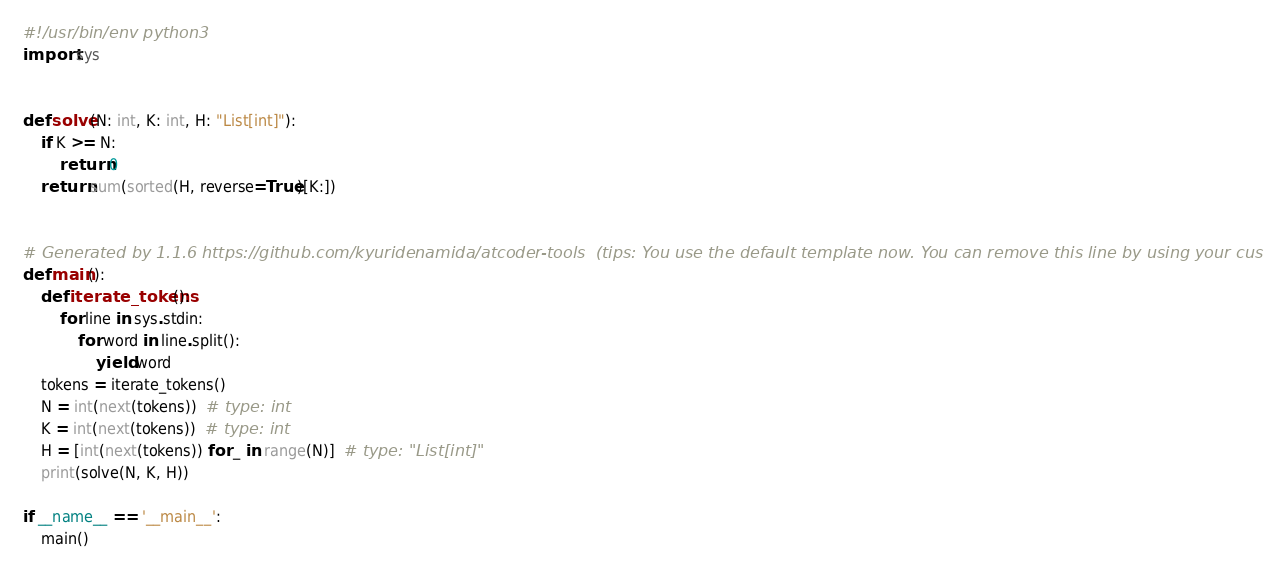Convert code to text. <code><loc_0><loc_0><loc_500><loc_500><_Python_>#!/usr/bin/env python3
import sys


def solve(N: int, K: int, H: "List[int]"):
    if K >= N:
        return 0
    return sum(sorted(H, reverse=True)[K:])


# Generated by 1.1.6 https://github.com/kyuridenamida/atcoder-tools  (tips: You use the default template now. You can remove this line by using your custom template)
def main():
    def iterate_tokens():
        for line in sys.stdin:
            for word in line.split():
                yield word
    tokens = iterate_tokens()
    N = int(next(tokens))  # type: int
    K = int(next(tokens))  # type: int
    H = [int(next(tokens)) for _ in range(N)]  # type: "List[int]"
    print(solve(N, K, H))

if __name__ == '__main__':
    main()
</code> 